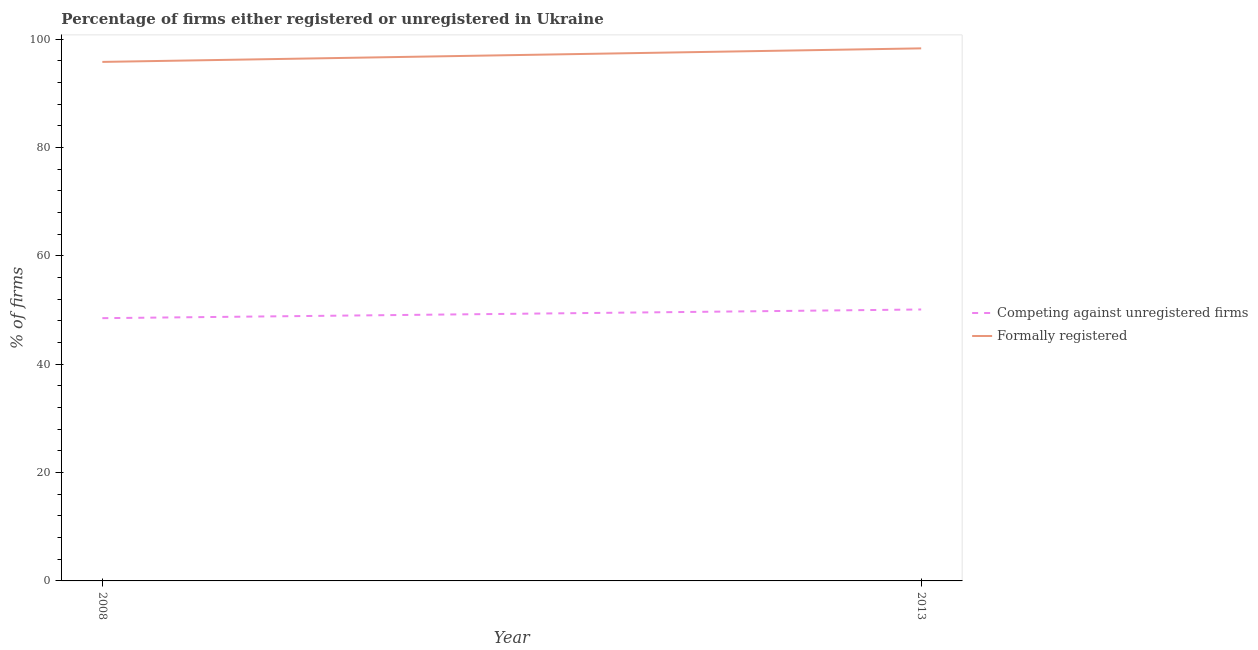What is the percentage of registered firms in 2008?
Give a very brief answer. 48.5. Across all years, what is the maximum percentage of registered firms?
Keep it short and to the point. 50.1. Across all years, what is the minimum percentage of registered firms?
Keep it short and to the point. 48.5. In which year was the percentage of registered firms maximum?
Your response must be concise. 2013. In which year was the percentage of registered firms minimum?
Offer a very short reply. 2008. What is the total percentage of formally registered firms in the graph?
Your answer should be very brief. 194.1. What is the difference between the percentage of formally registered firms in 2013 and the percentage of registered firms in 2008?
Offer a terse response. 49.8. What is the average percentage of registered firms per year?
Your answer should be very brief. 49.3. In the year 2013, what is the difference between the percentage of registered firms and percentage of formally registered firms?
Give a very brief answer. -48.2. In how many years, is the percentage of formally registered firms greater than 32 %?
Your answer should be compact. 2. What is the ratio of the percentage of formally registered firms in 2008 to that in 2013?
Your answer should be compact. 0.97. How many lines are there?
Provide a short and direct response. 2. How many years are there in the graph?
Give a very brief answer. 2. What is the difference between two consecutive major ticks on the Y-axis?
Give a very brief answer. 20. Are the values on the major ticks of Y-axis written in scientific E-notation?
Give a very brief answer. No. Does the graph contain any zero values?
Offer a very short reply. No. Does the graph contain grids?
Offer a very short reply. No. Where does the legend appear in the graph?
Offer a very short reply. Center right. How are the legend labels stacked?
Your response must be concise. Vertical. What is the title of the graph?
Offer a very short reply. Percentage of firms either registered or unregistered in Ukraine. What is the label or title of the Y-axis?
Give a very brief answer. % of firms. What is the % of firms of Competing against unregistered firms in 2008?
Keep it short and to the point. 48.5. What is the % of firms of Formally registered in 2008?
Your answer should be very brief. 95.8. What is the % of firms of Competing against unregistered firms in 2013?
Provide a short and direct response. 50.1. What is the % of firms of Formally registered in 2013?
Offer a very short reply. 98.3. Across all years, what is the maximum % of firms of Competing against unregistered firms?
Offer a very short reply. 50.1. Across all years, what is the maximum % of firms of Formally registered?
Your answer should be very brief. 98.3. Across all years, what is the minimum % of firms of Competing against unregistered firms?
Your response must be concise. 48.5. Across all years, what is the minimum % of firms of Formally registered?
Make the answer very short. 95.8. What is the total % of firms of Competing against unregistered firms in the graph?
Make the answer very short. 98.6. What is the total % of firms in Formally registered in the graph?
Provide a succinct answer. 194.1. What is the difference between the % of firms of Competing against unregistered firms in 2008 and the % of firms of Formally registered in 2013?
Provide a succinct answer. -49.8. What is the average % of firms of Competing against unregistered firms per year?
Make the answer very short. 49.3. What is the average % of firms in Formally registered per year?
Offer a very short reply. 97.05. In the year 2008, what is the difference between the % of firms of Competing against unregistered firms and % of firms of Formally registered?
Give a very brief answer. -47.3. In the year 2013, what is the difference between the % of firms in Competing against unregistered firms and % of firms in Formally registered?
Your answer should be very brief. -48.2. What is the ratio of the % of firms in Competing against unregistered firms in 2008 to that in 2013?
Provide a short and direct response. 0.97. What is the ratio of the % of firms of Formally registered in 2008 to that in 2013?
Your answer should be very brief. 0.97. What is the difference between the highest and the second highest % of firms in Competing against unregistered firms?
Offer a very short reply. 1.6. What is the difference between the highest and the second highest % of firms of Formally registered?
Keep it short and to the point. 2.5. 